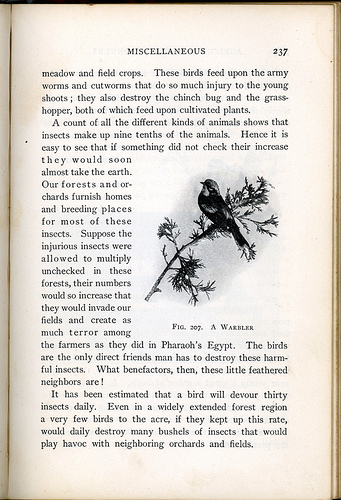Identify the text contained in this image. MISCELLANEOUS meadow and field crops destroy daily would they if acre, the to birds few very a insects daily. Even in widely extended will bird a that estimated been hiLs are neighbors WAKBLKH F these little feathered harm birds The these destory to has then benefactors, What insects. Egypt Pharaoh's man friends direct only the are the farmers as they in did among terror much fields and create our invade would they would increase that numbers their forests, unchecked in these multiply allowed injurious insects insects were the suppose these of most for and breeding places homes furnish chards forests Our almost take the oc and earth soon would they casay to see that something did not THE of tenths nine UP make insects hopper schools different the all of count A both of which also devour thirty region forest insocts kept up this rate would that fields and orchards neighbouring with Havoc play of bushels many they check animals their increase Hence it is that shows animals of kinds upon food destroy cultivated the chinch plants. bug and the grass- young the to injury much so do that cutworms and worms these birds food upon the army 237 